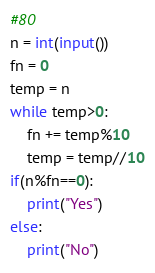Convert code to text. <code><loc_0><loc_0><loc_500><loc_500><_Python_>#80
n = int(input())
fn = 0
temp = n
while temp>0:
    fn += temp%10
    temp = temp//10
if(n%fn==0):
    print("Yes")
else:
    print("No")</code> 